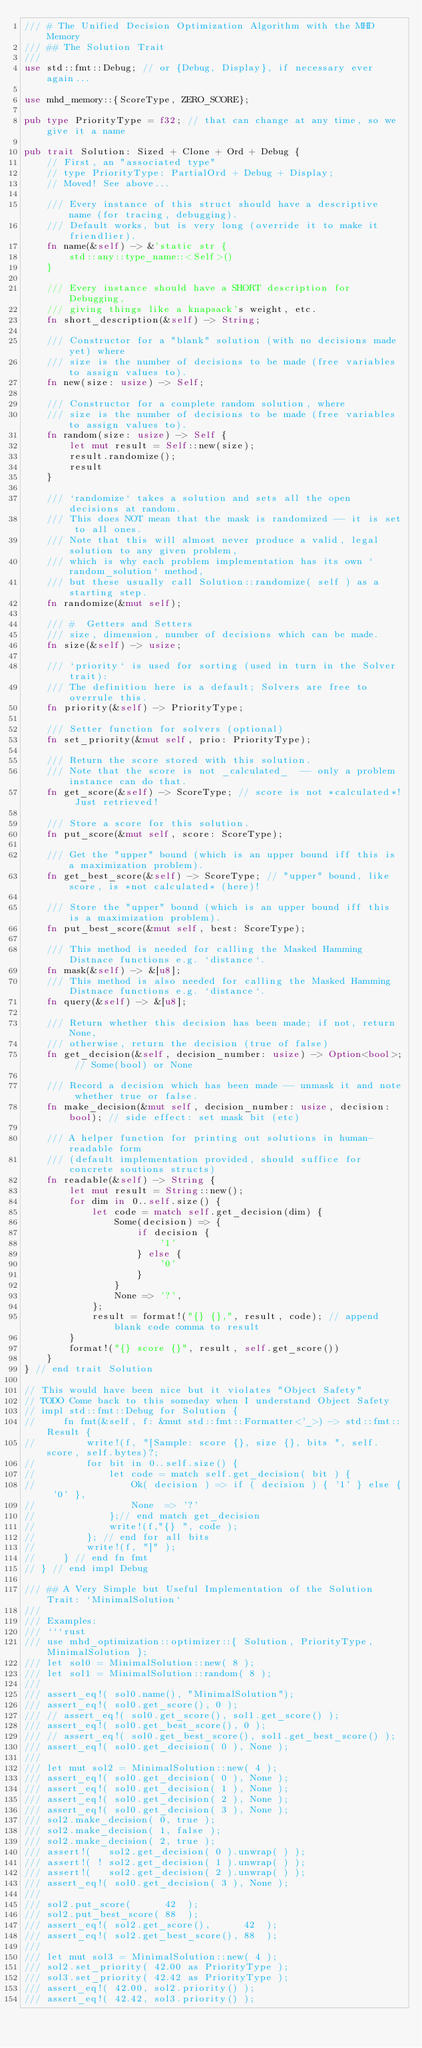<code> <loc_0><loc_0><loc_500><loc_500><_Rust_>/// # The Unified Decision Optimization Algorithm with the MHD Memory
/// ## The Solution Trait
///
use std::fmt::Debug; // or {Debug, Display}, if necessary ever again...

use mhd_memory::{ScoreType, ZERO_SCORE};

pub type PriorityType = f32; // that can change at any time, so we give it a name

pub trait Solution: Sized + Clone + Ord + Debug {
    // First, an "associated type"
    // type PriorityType: PartialOrd + Debug + Display;
    // Moved! See above...

    /// Every instance of this struct should have a descriptive name (for tracing, debugging).
    /// Default works, but is very long (override it to make it friendlier).
    fn name(&self) -> &'static str {
        std::any::type_name::<Self>()
    }

    /// Every instance should have a SHORT description for Debugging,
    /// giving things like a knapsack's weight, etc.
    fn short_description(&self) -> String;

    /// Constructor for a "blank" solution (with no decisions made yet) where
    /// size is the number of decisions to be made (free variables to assign values to).
    fn new(size: usize) -> Self;

    /// Constructor for a complete random solution, where
    /// size is the number of decisions to be made (free variables to assign values to).
    fn random(size: usize) -> Self {
        let mut result = Self::new(size);
        result.randomize();
        result
    }

    /// `randomize` takes a solution and sets all the open decisions at random.
    /// This does NOT mean that the mask is randomized -- it is set to all ones.
    /// Note that this will almost never produce a valid, legal solution to any given problem,
    /// which is why each problem implementation has its own `random_solution` method,
    /// but these usually call Solution::randomize( self ) as a starting step.
    fn randomize(&mut self);

    /// #  Getters and Setters
    /// size, dimension, number of decisions which can be made.
    fn size(&self) -> usize;

    /// `priority` is used for sorting (used in turn in the Solver trait):
    /// The definition here is a default; Solvers are free to overrule this.
    fn priority(&self) -> PriorityType;

    /// Setter function for solvers (optional)
    fn set_priority(&mut self, prio: PriorityType);

    /// Return the score stored with this solution.
    /// Note that the score is not _calculated_  -- only a problem instance can do that.
    fn get_score(&self) -> ScoreType; // score is not *calculated*! Just retrieved!

    /// Store a score for this solution.
    fn put_score(&mut self, score: ScoreType);

    /// Get the "upper" bound (which is an upper bound iff this is a maximization problem).
    fn get_best_score(&self) -> ScoreType; // "upper" bound, like score, is *not calculated* (here)!

    /// Store the "upper" bound (which is an upper bound iff this is a maximization problem).
    fn put_best_score(&mut self, best: ScoreType);

    /// This method is needed for calling the Masked Hamming Distnace functions e.g. `distance`.
    fn mask(&self) -> &[u8];
    /// This method is also needed for calling the Masked Hamming Distnace functions e.g. `distance`.
    fn query(&self) -> &[u8];

    /// Return whether this decision has been made; if not, return None,
    /// otherwise, return the decision (true of false)
    fn get_decision(&self, decision_number: usize) -> Option<bool>; // Some(bool) or None

    /// Record a decision which has been made -- unmask it and note whether true or false.
    fn make_decision(&mut self, decision_number: usize, decision: bool); // side effect: set mask bit (etc)

    /// A helper function for printing out solutions in human-readable form
    /// (default implementation provided, should suffice for concrete soutions structs)
    fn readable(&self) -> String {
        let mut result = String::new();
        for dim in 0..self.size() {
            let code = match self.get_decision(dim) {
                Some(decision) => {
                    if decision {
                        '1'
                    } else {
                        '0'
                    }
                }
                None => '?',
            };
            result = format!("{} {},", result, code); // append blank code comma to result
        }
        format!("{} score {}", result, self.get_score())
    }
} // end trait Solution

// This would have been nice but it violates "Object Safety"
// TODO Come back to this someday when I understand Object Safety
// impl std::fmt::Debug for Solution {
//     fn fmt(&self, f: &mut std::fmt::Formatter<'_>) -> std::fmt::Result {
//         write!(f, "[Sample: score {}, size {}, bits ", self.score, self.bytes)?;
//         for bit in 0..self.size() {
//             let code = match self.get_decision( bit ) {
//                 Ok( decision ) => if ( decision ) { '1' } else { '0' },
//                 None  => '?'
//             };// end match get_decision
//             write!(f,"{} ", code );
//         }; // end for all bits
//         write!(f, "]" );
//     } // end fn fmt
// } // end impl Debug

/// ## A Very Simple but Useful Implementation of the Solution Trait: `MinimalSolution`
///
/// Examples:
/// ```rust
/// use mhd_optimization::optimizer::{ Solution, PriorityType, MinimalSolution };
/// let sol0 = MinimalSolution::new( 8 );
/// let sol1 = MinimalSolution::random( 8 );
///
/// assert_eq!( sol0.name(), "MinimalSolution");
/// assert_eq!( sol0.get_score(), 0 );
/// // assert_eq!( sol0.get_score(), sol1.get_score() );
/// assert_eq!( sol0.get_best_score(), 0 );
/// // assert_eq!( sol0.get_best_score(), sol1.get_best_score() );
/// assert_eq!( sol0.get_decision( 0 ), None );
///
/// let mut sol2 = MinimalSolution::new( 4 );
/// assert_eq!( sol0.get_decision( 0 ), None );
/// assert_eq!( sol0.get_decision( 1 ), None );
/// assert_eq!( sol0.get_decision( 2 ), None );
/// assert_eq!( sol0.get_decision( 3 ), None );
/// sol2.make_decision( 0, true );
/// sol2.make_decision( 1, false );
/// sol2.make_decision( 2, true );
/// assert!(   sol2.get_decision( 0 ).unwrap( ) );
/// assert!( ! sol2.get_decision( 1 ).unwrap( ) );
/// assert!(   sol2.get_decision( 2 ).unwrap( ) );
/// assert_eq!( sol0.get_decision( 3 ), None );
///
/// sol2.put_score(      42  );
/// sol2.put_best_score( 88  );
/// assert_eq!( sol2.get_score(),      42  );
/// assert_eq!( sol2.get_best_score(), 88  );
///
/// let mut sol3 = MinimalSolution::new( 4 );
/// sol2.set_priority( 42.00 as PriorityType );
/// sol3.set_priority( 42.42 as PriorityType );
/// assert_eq!( 42.00, sol2.priority() );
/// assert_eq!( 42.42, sol3.priority() );</code> 